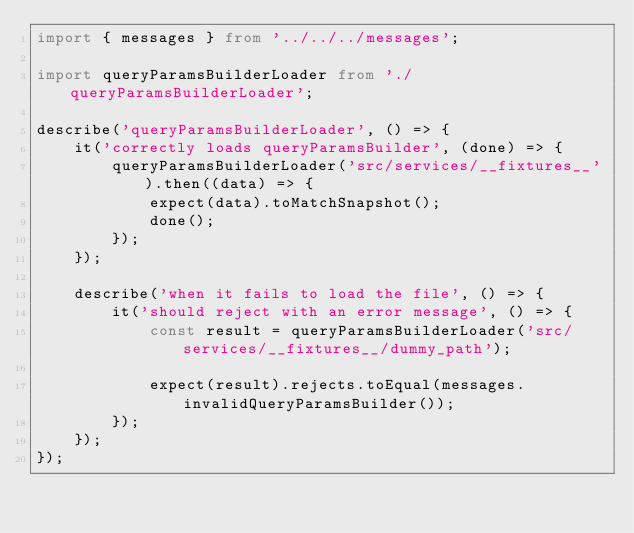<code> <loc_0><loc_0><loc_500><loc_500><_TypeScript_>import { messages } from '../../../messages';

import queryParamsBuilderLoader from './queryParamsBuilderLoader';

describe('queryParamsBuilderLoader', () => {
    it('correctly loads queryParamsBuilder', (done) => {
        queryParamsBuilderLoader('src/services/__fixtures__').then((data) => {
            expect(data).toMatchSnapshot();
            done();
        });
    });

    describe('when it fails to load the file', () => {
        it('should reject with an error message', () => {
            const result = queryParamsBuilderLoader('src/services/__fixtures__/dummy_path');

            expect(result).rejects.toEqual(messages.invalidQueryParamsBuilder());
        });
    });
});
</code> 